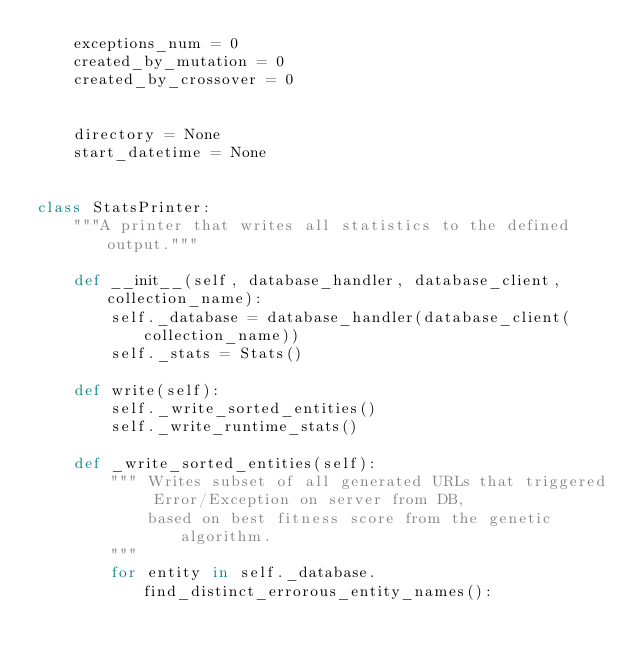Convert code to text. <code><loc_0><loc_0><loc_500><loc_500><_Python_>    exceptions_num = 0
    created_by_mutation = 0
    created_by_crossover = 0


    directory = None
    start_datetime = None


class StatsPrinter:
    """A printer that writes all statistics to the defined output."""

    def __init__(self, database_handler, database_client, collection_name):
        self._database = database_handler(database_client(collection_name))
        self._stats = Stats()

    def write(self):
        self._write_sorted_entities()
        self._write_runtime_stats()

    def _write_sorted_entities(self):
        """ Writes subset of all generated URLs that triggered Error/Exception on server from DB,
            based on best fitness score from the genetic algorithm.
        """
        for entity in self._database.find_distinct_errorous_entity_names():</code> 